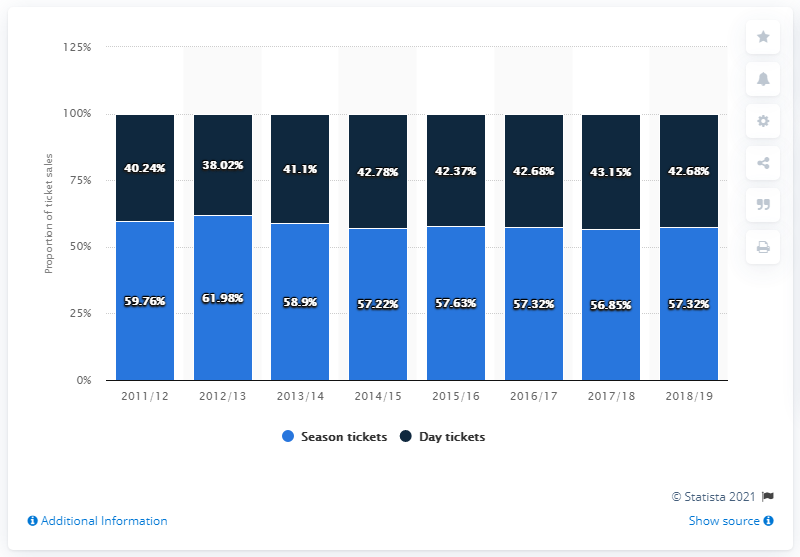Draw attention to some important aspects in this diagram. The difference in value between season tickets and day tickets in 2016/17 was 14.64. The lowest value in the light blue bar is 56.85. 